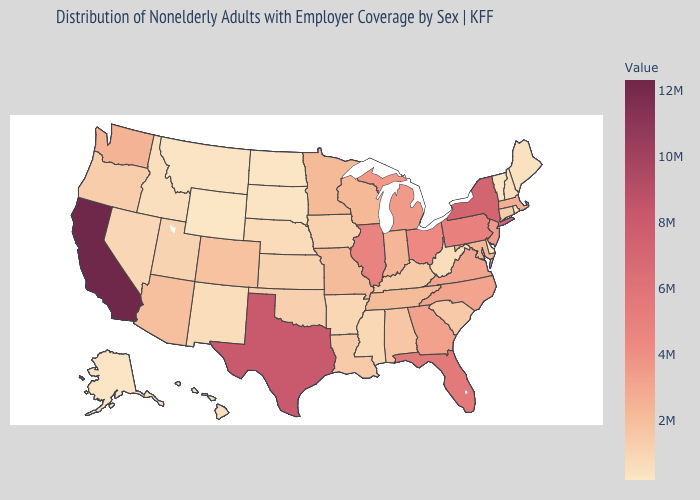Which states hav the highest value in the MidWest?
Short answer required. Illinois. Which states have the lowest value in the USA?
Write a very short answer. Wyoming. Among the states that border South Dakota , which have the lowest value?
Short answer required. Wyoming. Among the states that border Pennsylvania , which have the lowest value?
Be succinct. Delaware. Does New Jersey have the highest value in the USA?
Keep it brief. No. Among the states that border Connecticut , does New York have the highest value?
Give a very brief answer. Yes. 